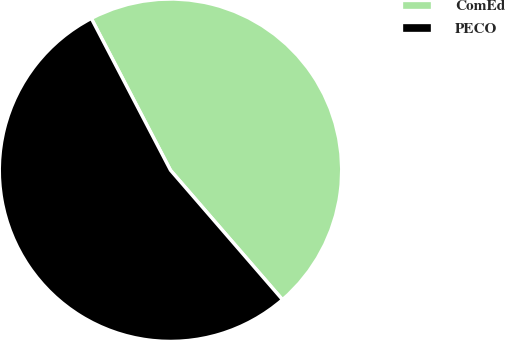Convert chart. <chart><loc_0><loc_0><loc_500><loc_500><pie_chart><fcel>ComEd<fcel>PECO<nl><fcel>46.3%<fcel>53.7%<nl></chart> 